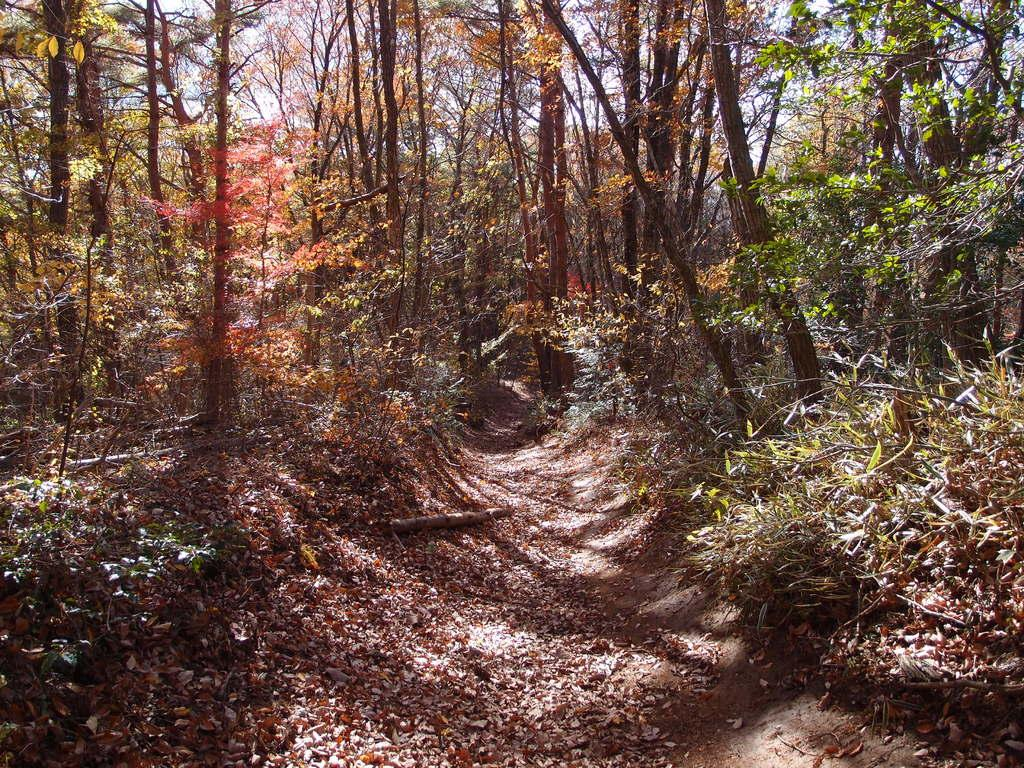What can be seen at the top of the image? The sky is visible towards the top of the image. What type of vegetation is present in the image? There are trees and plants in the image. What is visible at the bottom of the image? The ground is visible towards the bottom of the image. What is on the ground in the image? There are leaves on the ground. What type of glass can be seen in the image? There is no glass present in the image. How does the mist affect the visibility of the trees in the image? There is no mist present in the image; the trees are clearly visible. 